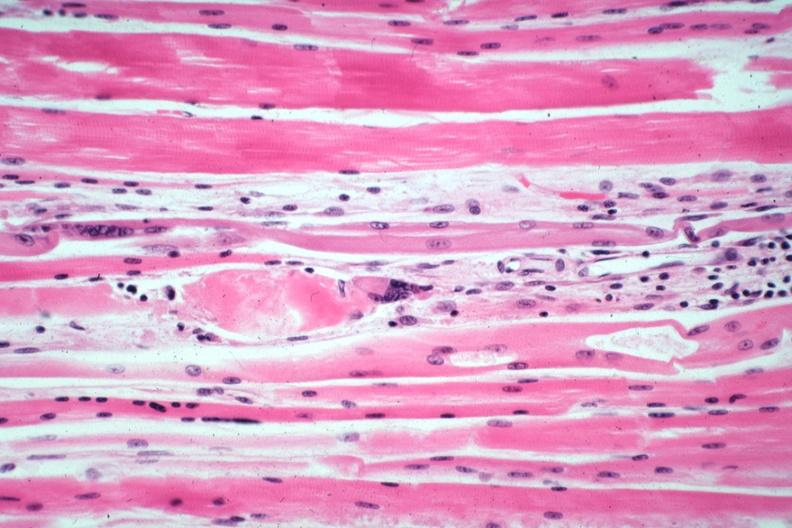s soft tissue present?
Answer the question using a single word or phrase. Yes 